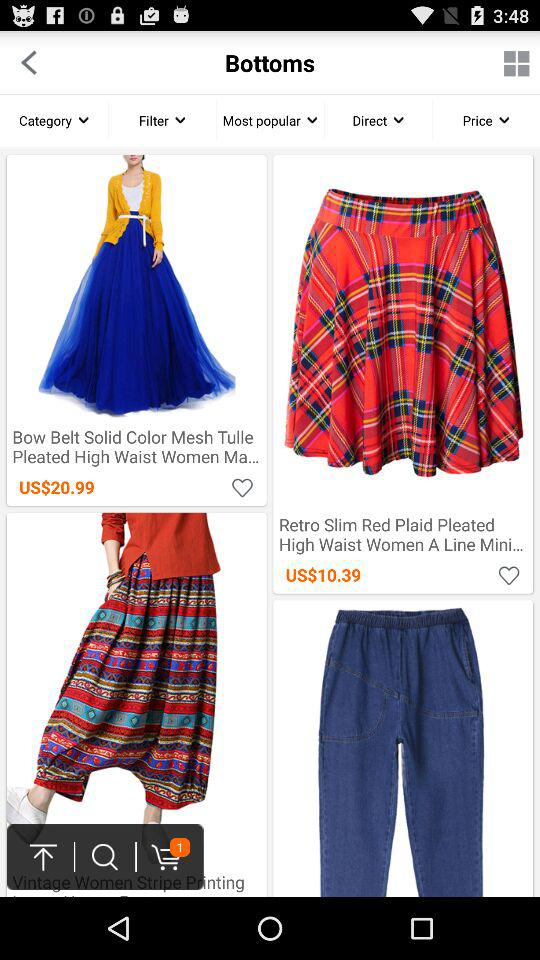How much does a "Bow Belt Solid Color Mesh Tulle Pleated High Waist Women Ma..." cost? The cost of "Bow Belt Solid Color Mesh Tulle Pleated High Waist Women Ma..." is US$20.99. 